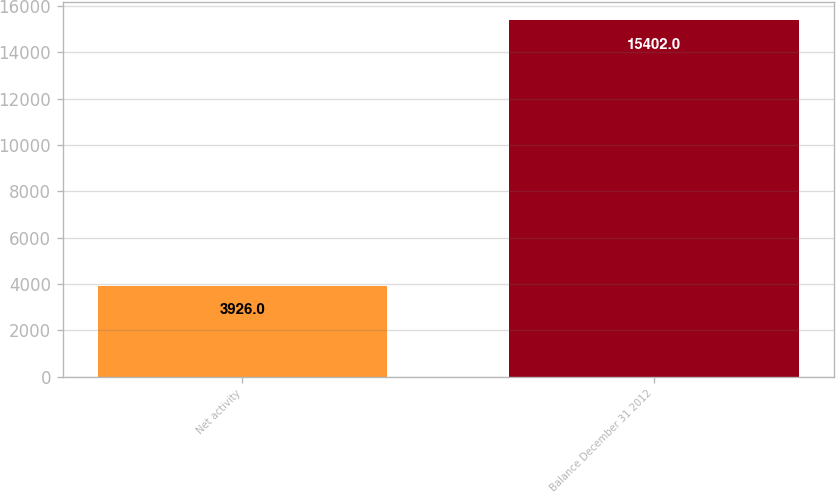<chart> <loc_0><loc_0><loc_500><loc_500><bar_chart><fcel>Net activity<fcel>Balance December 31 2012<nl><fcel>3926<fcel>15402<nl></chart> 